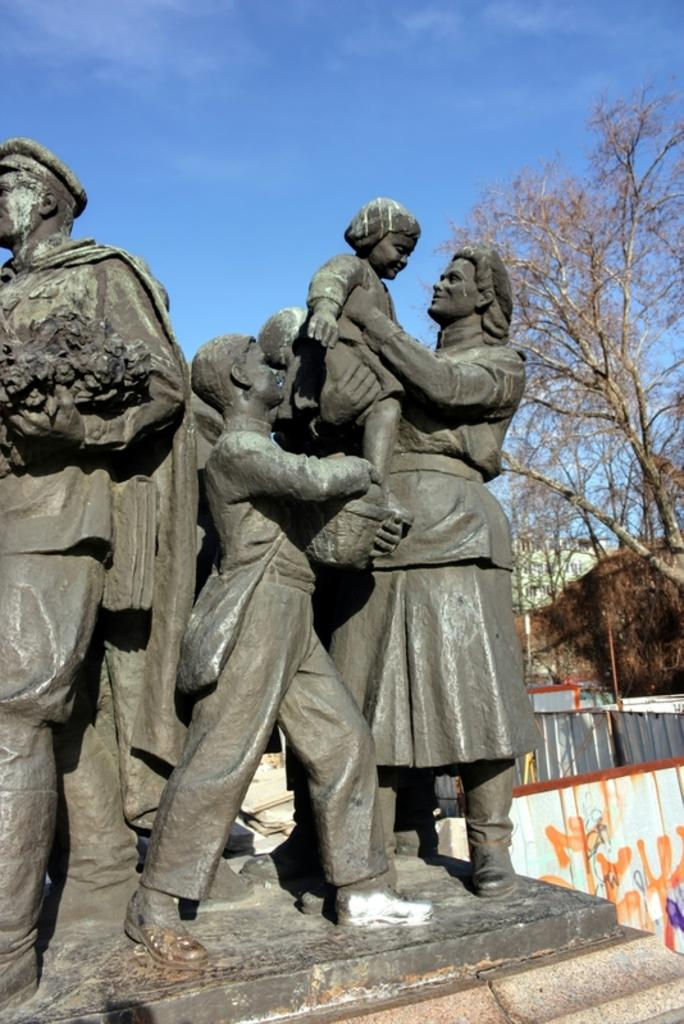What type of objects can be seen in the image? There are statues in the image. What is the color of the statues? The statues are gray in color. What can be seen in the background of the image? There are dried trees in the background of the image. What is the color of the sky in the image? The sky is blue in color. Is there a bee buzzing around the statues in the image? There is no bee present in the image; the focus is on the statues and their surroundings. 